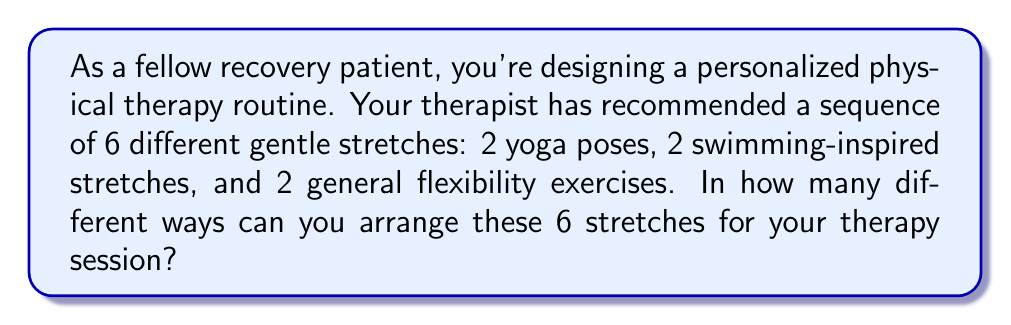Show me your answer to this math problem. Let's approach this step-by-step:

1) We have 6 distinct stretches to arrange. This is a permutation problem, as the order matters in a sequence.

2) The formula for permutations of n distinct objects is:

   $$P(n) = n!$$

   Where $n!$ represents the factorial of n.

3) In this case, $n = 6$, so we need to calculate $6!$

4) Let's expand this:

   $$6! = 6 \times 5 \times 4 \times 3 \times 2 \times 1$$

5) Calculating:

   $$6! = 720$$

This means there are 720 different ways to arrange these 6 stretches.

Note: This solution assumes that all stretches are considered distinct. For example, if the two yoga poses are different from each other, they are treated as separate entities in the arrangement.
Answer: $720$ 